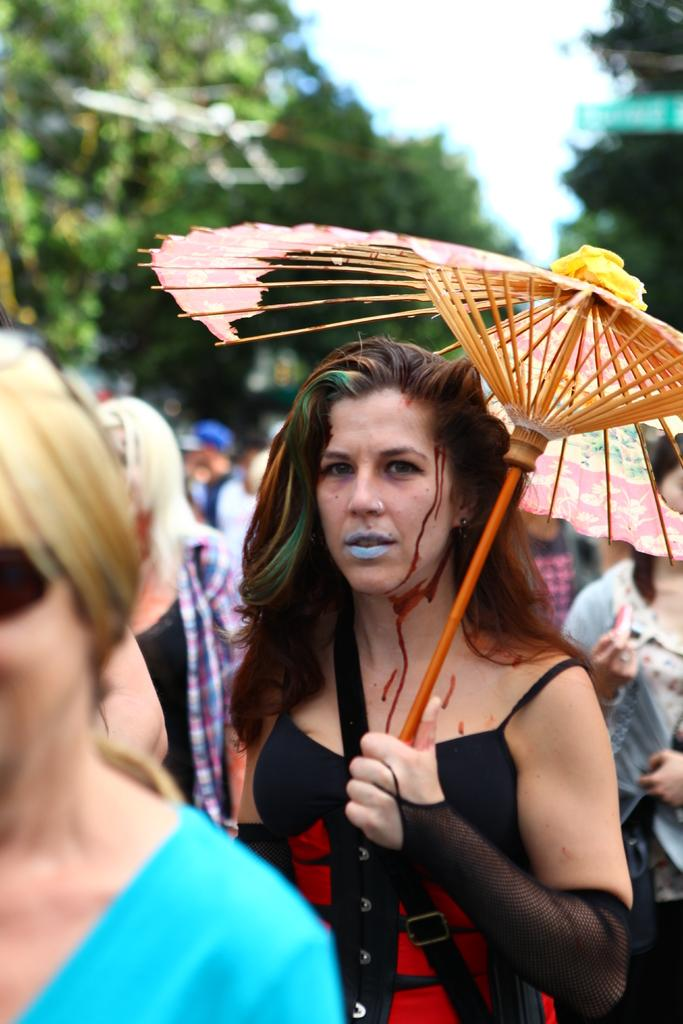Who is the main subject in the image? There is a woman in the image. What is the woman doing in the image? The woman is standing and holding an umbrella. What can be seen in the background of the image? There is a group of people, trees, and the sky visible in the background of the image. What type of nerve can be seen in the image? There is no nerve present in the image. Is there a chessboard visible in the image? There is no chessboard present in the image. 